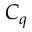<formula> <loc_0><loc_0><loc_500><loc_500>C _ { q }</formula> 